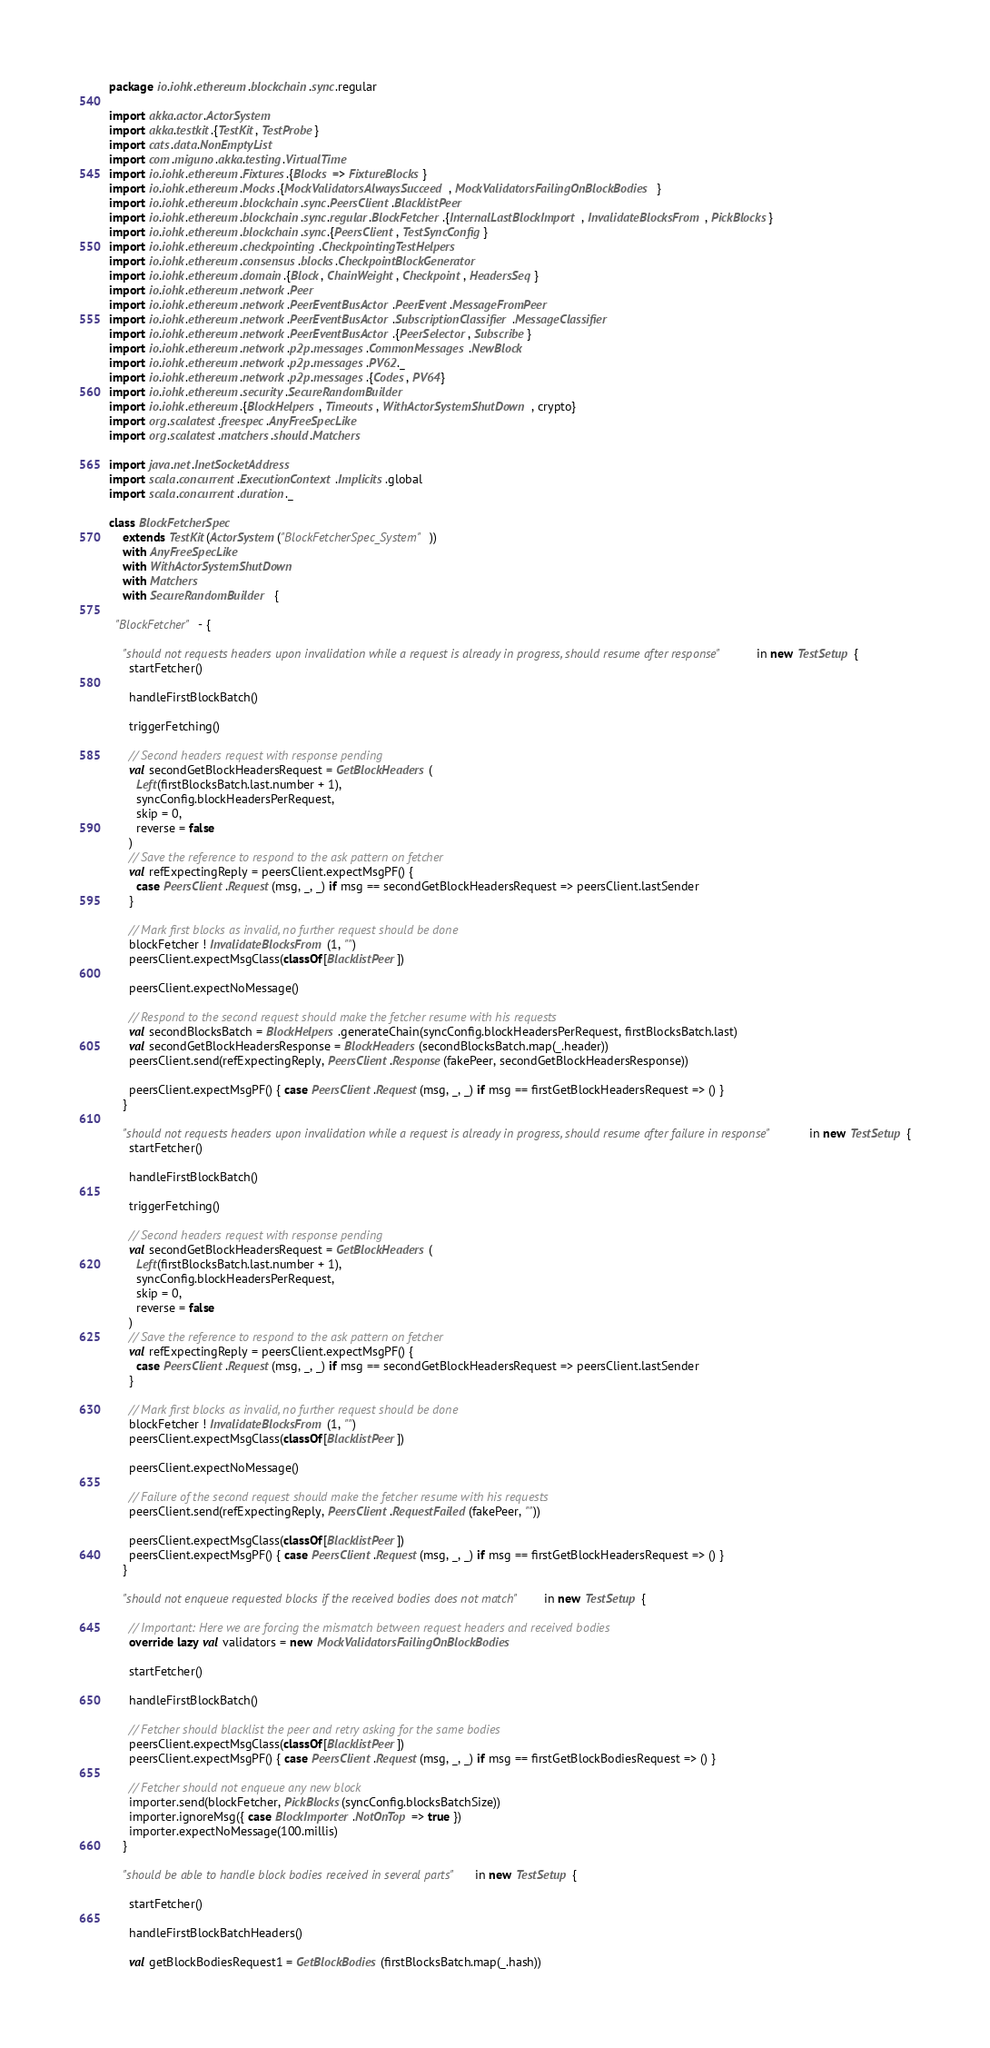Convert code to text. <code><loc_0><loc_0><loc_500><loc_500><_Scala_>package io.iohk.ethereum.blockchain.sync.regular

import akka.actor.ActorSystem
import akka.testkit.{TestKit, TestProbe}
import cats.data.NonEmptyList
import com.miguno.akka.testing.VirtualTime
import io.iohk.ethereum.Fixtures.{Blocks => FixtureBlocks}
import io.iohk.ethereum.Mocks.{MockValidatorsAlwaysSucceed, MockValidatorsFailingOnBlockBodies}
import io.iohk.ethereum.blockchain.sync.PeersClient.BlacklistPeer
import io.iohk.ethereum.blockchain.sync.regular.BlockFetcher.{InternalLastBlockImport, InvalidateBlocksFrom, PickBlocks}
import io.iohk.ethereum.blockchain.sync.{PeersClient, TestSyncConfig}
import io.iohk.ethereum.checkpointing.CheckpointingTestHelpers
import io.iohk.ethereum.consensus.blocks.CheckpointBlockGenerator
import io.iohk.ethereum.domain.{Block, ChainWeight, Checkpoint, HeadersSeq}
import io.iohk.ethereum.network.Peer
import io.iohk.ethereum.network.PeerEventBusActor.PeerEvent.MessageFromPeer
import io.iohk.ethereum.network.PeerEventBusActor.SubscriptionClassifier.MessageClassifier
import io.iohk.ethereum.network.PeerEventBusActor.{PeerSelector, Subscribe}
import io.iohk.ethereum.network.p2p.messages.CommonMessages.NewBlock
import io.iohk.ethereum.network.p2p.messages.PV62._
import io.iohk.ethereum.network.p2p.messages.{Codes, PV64}
import io.iohk.ethereum.security.SecureRandomBuilder
import io.iohk.ethereum.{BlockHelpers, Timeouts, WithActorSystemShutDown, crypto}
import org.scalatest.freespec.AnyFreeSpecLike
import org.scalatest.matchers.should.Matchers

import java.net.InetSocketAddress
import scala.concurrent.ExecutionContext.Implicits.global
import scala.concurrent.duration._

class BlockFetcherSpec
    extends TestKit(ActorSystem("BlockFetcherSpec_System"))
    with AnyFreeSpecLike
    with WithActorSystemShutDown
    with Matchers
    with SecureRandomBuilder {

  "BlockFetcher" - {

    "should not requests headers upon invalidation while a request is already in progress, should resume after response" in new TestSetup {
      startFetcher()

      handleFirstBlockBatch()

      triggerFetching()

      // Second headers request with response pending
      val secondGetBlockHeadersRequest = GetBlockHeaders(
        Left(firstBlocksBatch.last.number + 1),
        syncConfig.blockHeadersPerRequest,
        skip = 0,
        reverse = false
      )
      // Save the reference to respond to the ask pattern on fetcher
      val refExpectingReply = peersClient.expectMsgPF() {
        case PeersClient.Request(msg, _, _) if msg == secondGetBlockHeadersRequest => peersClient.lastSender
      }

      // Mark first blocks as invalid, no further request should be done
      blockFetcher ! InvalidateBlocksFrom(1, "")
      peersClient.expectMsgClass(classOf[BlacklistPeer])

      peersClient.expectNoMessage()

      // Respond to the second request should make the fetcher resume with his requests
      val secondBlocksBatch = BlockHelpers.generateChain(syncConfig.blockHeadersPerRequest, firstBlocksBatch.last)
      val secondGetBlockHeadersResponse = BlockHeaders(secondBlocksBatch.map(_.header))
      peersClient.send(refExpectingReply, PeersClient.Response(fakePeer, secondGetBlockHeadersResponse))

      peersClient.expectMsgPF() { case PeersClient.Request(msg, _, _) if msg == firstGetBlockHeadersRequest => () }
    }

    "should not requests headers upon invalidation while a request is already in progress, should resume after failure in response" in new TestSetup {
      startFetcher()

      handleFirstBlockBatch()

      triggerFetching()

      // Second headers request with response pending
      val secondGetBlockHeadersRequest = GetBlockHeaders(
        Left(firstBlocksBatch.last.number + 1),
        syncConfig.blockHeadersPerRequest,
        skip = 0,
        reverse = false
      )
      // Save the reference to respond to the ask pattern on fetcher
      val refExpectingReply = peersClient.expectMsgPF() {
        case PeersClient.Request(msg, _, _) if msg == secondGetBlockHeadersRequest => peersClient.lastSender
      }

      // Mark first blocks as invalid, no further request should be done
      blockFetcher ! InvalidateBlocksFrom(1, "")
      peersClient.expectMsgClass(classOf[BlacklistPeer])

      peersClient.expectNoMessage()

      // Failure of the second request should make the fetcher resume with his requests
      peersClient.send(refExpectingReply, PeersClient.RequestFailed(fakePeer, ""))

      peersClient.expectMsgClass(classOf[BlacklistPeer])
      peersClient.expectMsgPF() { case PeersClient.Request(msg, _, _) if msg == firstGetBlockHeadersRequest => () }
    }

    "should not enqueue requested blocks if the received bodies does not match" in new TestSetup {

      // Important: Here we are forcing the mismatch between request headers and received bodies
      override lazy val validators = new MockValidatorsFailingOnBlockBodies

      startFetcher()

      handleFirstBlockBatch()

      // Fetcher should blacklist the peer and retry asking for the same bodies
      peersClient.expectMsgClass(classOf[BlacklistPeer])
      peersClient.expectMsgPF() { case PeersClient.Request(msg, _, _) if msg == firstGetBlockBodiesRequest => () }

      // Fetcher should not enqueue any new block
      importer.send(blockFetcher, PickBlocks(syncConfig.blocksBatchSize))
      importer.ignoreMsg({ case BlockImporter.NotOnTop => true })
      importer.expectNoMessage(100.millis)
    }

    "should be able to handle block bodies received in several parts" in new TestSetup {

      startFetcher()

      handleFirstBlockBatchHeaders()

      val getBlockBodiesRequest1 = GetBlockBodies(firstBlocksBatch.map(_.hash))</code> 